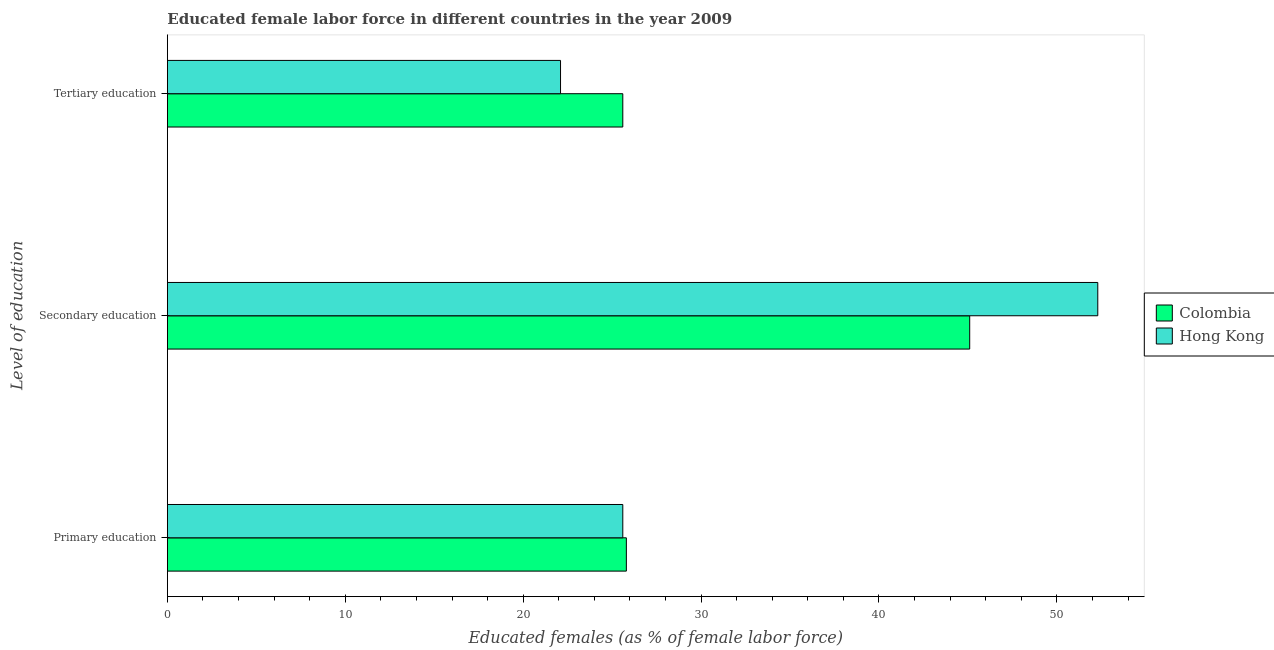How many groups of bars are there?
Your response must be concise. 3. Are the number of bars per tick equal to the number of legend labels?
Your answer should be compact. Yes. What is the label of the 1st group of bars from the top?
Your response must be concise. Tertiary education. What is the percentage of female labor force who received secondary education in Hong Kong?
Provide a succinct answer. 52.3. Across all countries, what is the maximum percentage of female labor force who received tertiary education?
Make the answer very short. 25.6. Across all countries, what is the minimum percentage of female labor force who received primary education?
Offer a very short reply. 25.6. In which country was the percentage of female labor force who received primary education maximum?
Keep it short and to the point. Colombia. In which country was the percentage of female labor force who received primary education minimum?
Your answer should be very brief. Hong Kong. What is the total percentage of female labor force who received primary education in the graph?
Offer a terse response. 51.4. What is the difference between the percentage of female labor force who received primary education in Colombia and that in Hong Kong?
Offer a terse response. 0.2. What is the difference between the percentage of female labor force who received tertiary education in Colombia and the percentage of female labor force who received primary education in Hong Kong?
Ensure brevity in your answer.  0. What is the average percentage of female labor force who received secondary education per country?
Give a very brief answer. 48.7. What is the difference between the percentage of female labor force who received tertiary education and percentage of female labor force who received primary education in Hong Kong?
Your answer should be very brief. -3.5. In how many countries, is the percentage of female labor force who received secondary education greater than 28 %?
Give a very brief answer. 2. What is the ratio of the percentage of female labor force who received tertiary education in Colombia to that in Hong Kong?
Keep it short and to the point. 1.16. Is the percentage of female labor force who received secondary education in Hong Kong less than that in Colombia?
Your answer should be compact. No. What is the difference between the highest and the second highest percentage of female labor force who received primary education?
Give a very brief answer. 0.2. What is the difference between the highest and the lowest percentage of female labor force who received primary education?
Provide a succinct answer. 0.2. In how many countries, is the percentage of female labor force who received tertiary education greater than the average percentage of female labor force who received tertiary education taken over all countries?
Your answer should be compact. 1. Is the sum of the percentage of female labor force who received tertiary education in Hong Kong and Colombia greater than the maximum percentage of female labor force who received secondary education across all countries?
Make the answer very short. No. What does the 1st bar from the top in Primary education represents?
Keep it short and to the point. Hong Kong. What does the 2nd bar from the bottom in Secondary education represents?
Your answer should be compact. Hong Kong. How many bars are there?
Provide a succinct answer. 6. What is the difference between two consecutive major ticks on the X-axis?
Your response must be concise. 10. Are the values on the major ticks of X-axis written in scientific E-notation?
Make the answer very short. No. Does the graph contain any zero values?
Your answer should be compact. No. How are the legend labels stacked?
Your response must be concise. Vertical. What is the title of the graph?
Your answer should be compact. Educated female labor force in different countries in the year 2009. What is the label or title of the X-axis?
Make the answer very short. Educated females (as % of female labor force). What is the label or title of the Y-axis?
Ensure brevity in your answer.  Level of education. What is the Educated females (as % of female labor force) in Colombia in Primary education?
Keep it short and to the point. 25.8. What is the Educated females (as % of female labor force) in Hong Kong in Primary education?
Offer a terse response. 25.6. What is the Educated females (as % of female labor force) in Colombia in Secondary education?
Give a very brief answer. 45.1. What is the Educated females (as % of female labor force) of Hong Kong in Secondary education?
Offer a terse response. 52.3. What is the Educated females (as % of female labor force) of Colombia in Tertiary education?
Offer a very short reply. 25.6. What is the Educated females (as % of female labor force) of Hong Kong in Tertiary education?
Your answer should be compact. 22.1. Across all Level of education, what is the maximum Educated females (as % of female labor force) in Colombia?
Make the answer very short. 45.1. Across all Level of education, what is the maximum Educated females (as % of female labor force) in Hong Kong?
Offer a very short reply. 52.3. Across all Level of education, what is the minimum Educated females (as % of female labor force) in Colombia?
Provide a succinct answer. 25.6. Across all Level of education, what is the minimum Educated females (as % of female labor force) of Hong Kong?
Your answer should be very brief. 22.1. What is the total Educated females (as % of female labor force) of Colombia in the graph?
Give a very brief answer. 96.5. What is the difference between the Educated females (as % of female labor force) in Colombia in Primary education and that in Secondary education?
Give a very brief answer. -19.3. What is the difference between the Educated females (as % of female labor force) of Hong Kong in Primary education and that in Secondary education?
Your answer should be compact. -26.7. What is the difference between the Educated females (as % of female labor force) in Colombia in Secondary education and that in Tertiary education?
Provide a short and direct response. 19.5. What is the difference between the Educated females (as % of female labor force) in Hong Kong in Secondary education and that in Tertiary education?
Give a very brief answer. 30.2. What is the difference between the Educated females (as % of female labor force) in Colombia in Primary education and the Educated females (as % of female labor force) in Hong Kong in Secondary education?
Your answer should be very brief. -26.5. What is the difference between the Educated females (as % of female labor force) of Colombia in Primary education and the Educated females (as % of female labor force) of Hong Kong in Tertiary education?
Your answer should be very brief. 3.7. What is the difference between the Educated females (as % of female labor force) in Colombia in Secondary education and the Educated females (as % of female labor force) in Hong Kong in Tertiary education?
Keep it short and to the point. 23. What is the average Educated females (as % of female labor force) of Colombia per Level of education?
Give a very brief answer. 32.17. What is the average Educated females (as % of female labor force) of Hong Kong per Level of education?
Give a very brief answer. 33.33. What is the difference between the Educated females (as % of female labor force) of Colombia and Educated females (as % of female labor force) of Hong Kong in Primary education?
Offer a terse response. 0.2. What is the difference between the Educated females (as % of female labor force) in Colombia and Educated females (as % of female labor force) in Hong Kong in Tertiary education?
Keep it short and to the point. 3.5. What is the ratio of the Educated females (as % of female labor force) in Colombia in Primary education to that in Secondary education?
Your response must be concise. 0.57. What is the ratio of the Educated females (as % of female labor force) in Hong Kong in Primary education to that in Secondary education?
Your answer should be compact. 0.49. What is the ratio of the Educated females (as % of female labor force) of Colombia in Primary education to that in Tertiary education?
Give a very brief answer. 1.01. What is the ratio of the Educated females (as % of female labor force) in Hong Kong in Primary education to that in Tertiary education?
Give a very brief answer. 1.16. What is the ratio of the Educated females (as % of female labor force) of Colombia in Secondary education to that in Tertiary education?
Make the answer very short. 1.76. What is the ratio of the Educated females (as % of female labor force) of Hong Kong in Secondary education to that in Tertiary education?
Give a very brief answer. 2.37. What is the difference between the highest and the second highest Educated females (as % of female labor force) of Colombia?
Ensure brevity in your answer.  19.3. What is the difference between the highest and the second highest Educated females (as % of female labor force) of Hong Kong?
Ensure brevity in your answer.  26.7. What is the difference between the highest and the lowest Educated females (as % of female labor force) in Hong Kong?
Your answer should be very brief. 30.2. 